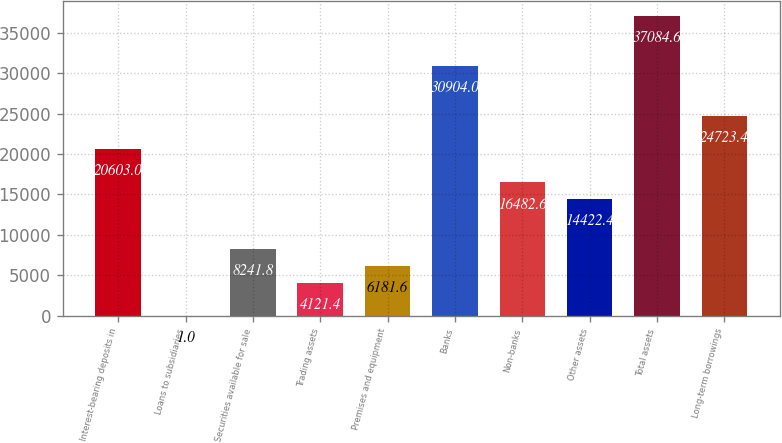Convert chart. <chart><loc_0><loc_0><loc_500><loc_500><bar_chart><fcel>Interest-bearing deposits in<fcel>Loans to subsidiaries<fcel>Securities available for sale<fcel>Trading assets<fcel>Premises and equipment<fcel>Banks<fcel>Non-banks<fcel>Other assets<fcel>Total assets<fcel>Long-term borrowings<nl><fcel>20603<fcel>1<fcel>8241.8<fcel>4121.4<fcel>6181.6<fcel>30904<fcel>16482.6<fcel>14422.4<fcel>37084.6<fcel>24723.4<nl></chart> 